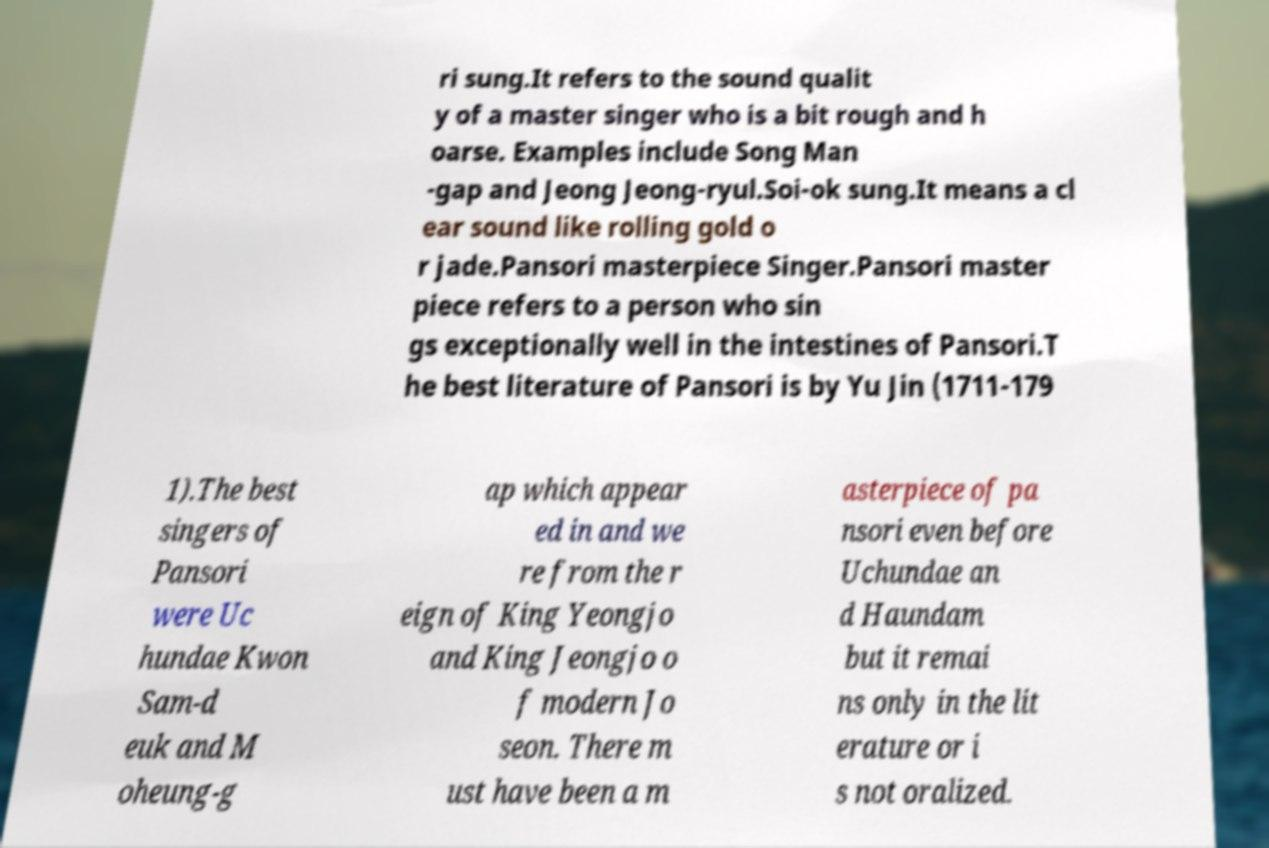There's text embedded in this image that I need extracted. Can you transcribe it verbatim? ri sung.It refers to the sound qualit y of a master singer who is a bit rough and h oarse. Examples include Song Man -gap and Jeong Jeong-ryul.Soi-ok sung.It means a cl ear sound like rolling gold o r jade.Pansori masterpiece Singer.Pansori master piece refers to a person who sin gs exceptionally well in the intestines of Pansori.T he best literature of Pansori is by Yu Jin (1711-179 1).The best singers of Pansori were Uc hundae Kwon Sam-d euk and M oheung-g ap which appear ed in and we re from the r eign of King Yeongjo and King Jeongjo o f modern Jo seon. There m ust have been a m asterpiece of pa nsori even before Uchundae an d Haundam but it remai ns only in the lit erature or i s not oralized. 